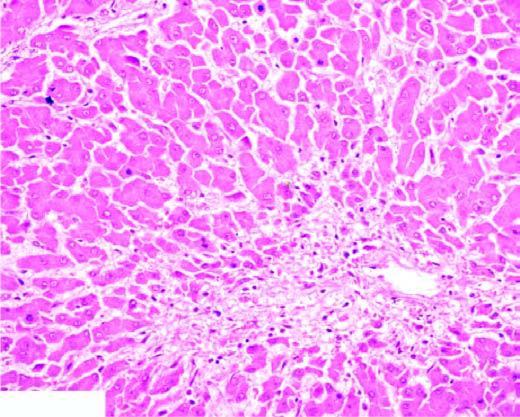what does the peripheral zone show?
Answer the question using a single word or phrase. Mild fatty change of liver cells 